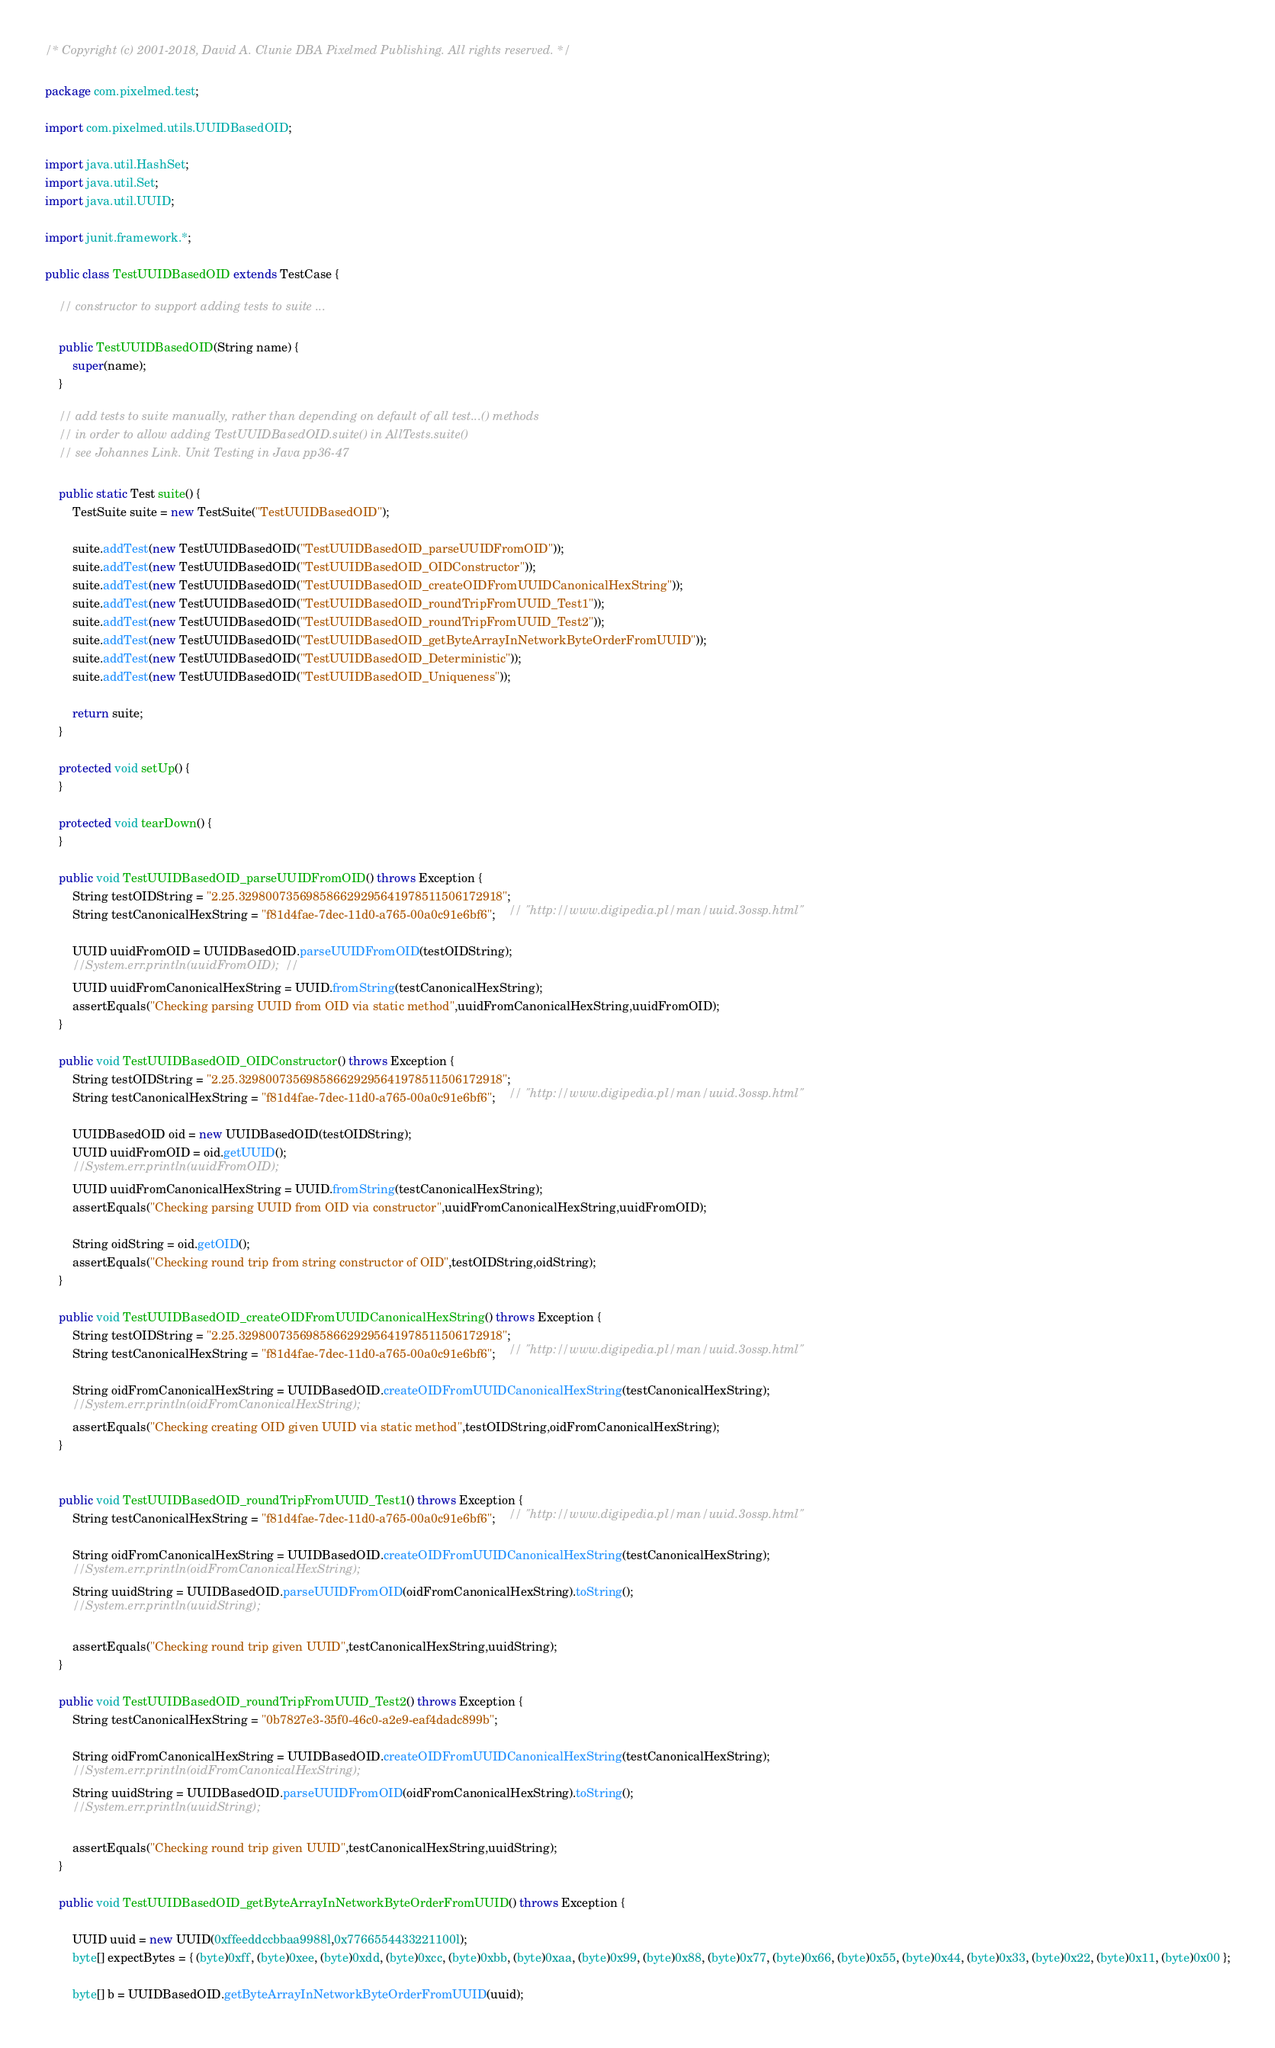Convert code to text. <code><loc_0><loc_0><loc_500><loc_500><_Java_>/* Copyright (c) 2001-2018, David A. Clunie DBA Pixelmed Publishing. All rights reserved. */

package com.pixelmed.test;

import com.pixelmed.utils.UUIDBasedOID;

import java.util.HashSet;
import java.util.Set;
import java.util.UUID;

import junit.framework.*;

public class TestUUIDBasedOID extends TestCase {
	
	// constructor to support adding tests to suite ...
	
	public TestUUIDBasedOID(String name) {
		super(name);
	}
	
	// add tests to suite manually, rather than depending on default of all test...() methods
	// in order to allow adding TestUUIDBasedOID.suite() in AllTests.suite()
	// see Johannes Link. Unit Testing in Java pp36-47
	
	public static Test suite() {
		TestSuite suite = new TestSuite("TestUUIDBasedOID");
		
		suite.addTest(new TestUUIDBasedOID("TestUUIDBasedOID_parseUUIDFromOID"));
		suite.addTest(new TestUUIDBasedOID("TestUUIDBasedOID_OIDConstructor"));
		suite.addTest(new TestUUIDBasedOID("TestUUIDBasedOID_createOIDFromUUIDCanonicalHexString"));
		suite.addTest(new TestUUIDBasedOID("TestUUIDBasedOID_roundTripFromUUID_Test1"));
		suite.addTest(new TestUUIDBasedOID("TestUUIDBasedOID_roundTripFromUUID_Test2"));
		suite.addTest(new TestUUIDBasedOID("TestUUIDBasedOID_getByteArrayInNetworkByteOrderFromUUID"));
		suite.addTest(new TestUUIDBasedOID("TestUUIDBasedOID_Deterministic"));
		suite.addTest(new TestUUIDBasedOID("TestUUIDBasedOID_Uniqueness"));
		
		return suite;
	}
	
	protected void setUp() {
	}
	
	protected void tearDown() {
	}
	
	public void TestUUIDBasedOID_parseUUIDFromOID() throws Exception {
		String testOIDString = "2.25.329800735698586629295641978511506172918";
		String testCanonicalHexString = "f81d4fae-7dec-11d0-a765-00a0c91e6bf6";	// "http://www.digipedia.pl/man/uuid.3ossp.html"
		
		UUID uuidFromOID = UUIDBasedOID.parseUUIDFromOID(testOIDString);
		//System.err.println(uuidFromOID);	// 
		UUID uuidFromCanonicalHexString = UUID.fromString(testCanonicalHexString);
		assertEquals("Checking parsing UUID from OID via static method",uuidFromCanonicalHexString,uuidFromOID);
	}
	
	public void TestUUIDBasedOID_OIDConstructor() throws Exception {
		String testOIDString = "2.25.329800735698586629295641978511506172918";
		String testCanonicalHexString = "f81d4fae-7dec-11d0-a765-00a0c91e6bf6";	// "http://www.digipedia.pl/man/uuid.3ossp.html"
		
		UUIDBasedOID oid = new UUIDBasedOID(testOIDString);
		UUID uuidFromOID = oid.getUUID();
		//System.err.println(uuidFromOID);
		UUID uuidFromCanonicalHexString = UUID.fromString(testCanonicalHexString);
		assertEquals("Checking parsing UUID from OID via constructor",uuidFromCanonicalHexString,uuidFromOID);

		String oidString = oid.getOID();
		assertEquals("Checking round trip from string constructor of OID",testOIDString,oidString);
	}

	public void TestUUIDBasedOID_createOIDFromUUIDCanonicalHexString() throws Exception {
		String testOIDString = "2.25.329800735698586629295641978511506172918";
		String testCanonicalHexString = "f81d4fae-7dec-11d0-a765-00a0c91e6bf6";	// "http://www.digipedia.pl/man/uuid.3ossp.html"
		
		String oidFromCanonicalHexString = UUIDBasedOID.createOIDFromUUIDCanonicalHexString(testCanonicalHexString);
		//System.err.println(oidFromCanonicalHexString);
		assertEquals("Checking creating OID given UUID via static method",testOIDString,oidFromCanonicalHexString);
	}


	public void TestUUIDBasedOID_roundTripFromUUID_Test1() throws Exception {
		String testCanonicalHexString = "f81d4fae-7dec-11d0-a765-00a0c91e6bf6";	// "http://www.digipedia.pl/man/uuid.3ossp.html"
					
		String oidFromCanonicalHexString = UUIDBasedOID.createOIDFromUUIDCanonicalHexString(testCanonicalHexString);
		//System.err.println(oidFromCanonicalHexString);
		String uuidString = UUIDBasedOID.parseUUIDFromOID(oidFromCanonicalHexString).toString();
		//System.err.println(uuidString);
			
		assertEquals("Checking round trip given UUID",testCanonicalHexString,uuidString);
	}

	public void TestUUIDBasedOID_roundTripFromUUID_Test2() throws Exception {
		String testCanonicalHexString = "0b7827e3-35f0-46c0-a2e9-eaf4dadc899b";
		
		String oidFromCanonicalHexString = UUIDBasedOID.createOIDFromUUIDCanonicalHexString(testCanonicalHexString);
		//System.err.println(oidFromCanonicalHexString);
		String uuidString = UUIDBasedOID.parseUUIDFromOID(oidFromCanonicalHexString).toString();
		//System.err.println(uuidString);
			
		assertEquals("Checking round trip given UUID",testCanonicalHexString,uuidString);
	}

	public void TestUUIDBasedOID_getByteArrayInNetworkByteOrderFromUUID() throws Exception {
		
		UUID uuid = new UUID(0xffeeddccbbaa9988l,0x7766554433221100l);
		byte[] expectBytes = { (byte)0xff, (byte)0xee, (byte)0xdd, (byte)0xcc, (byte)0xbb, (byte)0xaa, (byte)0x99, (byte)0x88, (byte)0x77, (byte)0x66, (byte)0x55, (byte)0x44, (byte)0x33, (byte)0x22, (byte)0x11, (byte)0x00 };

		byte[] b = UUIDBasedOID.getByteArrayInNetworkByteOrderFromUUID(uuid);</code> 